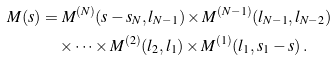Convert formula to latex. <formula><loc_0><loc_0><loc_500><loc_500>M ( s ) & = M ^ { ( N ) } ( s - s _ { N } , l _ { N - 1 } ) \times M ^ { ( N - 1 ) } ( l _ { N - 1 } , l _ { N - 2 } ) \\ & \quad \times \dots \times M ^ { ( 2 ) } ( l _ { 2 } , l _ { 1 } ) \times M ^ { ( 1 ) } ( l _ { 1 } , s _ { 1 } - s ) \, .</formula> 